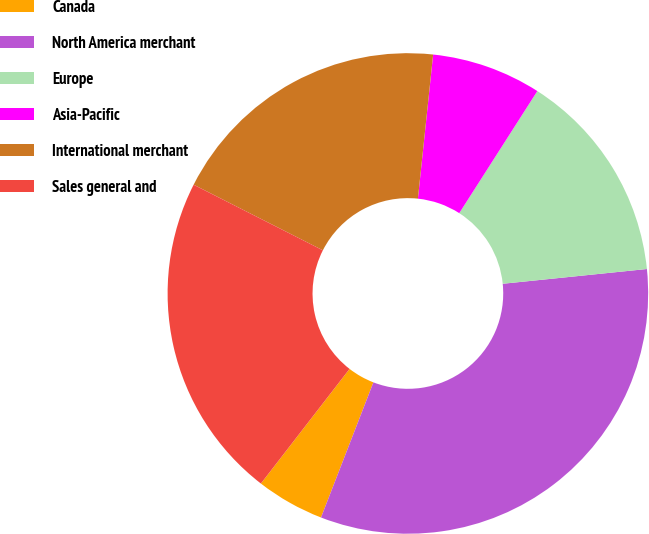Convert chart to OTSL. <chart><loc_0><loc_0><loc_500><loc_500><pie_chart><fcel>Canada<fcel>North America merchant<fcel>Europe<fcel>Asia-Pacific<fcel>International merchant<fcel>Sales general and<nl><fcel>4.59%<fcel>32.51%<fcel>14.32%<fcel>7.38%<fcel>19.2%<fcel>22.0%<nl></chart> 